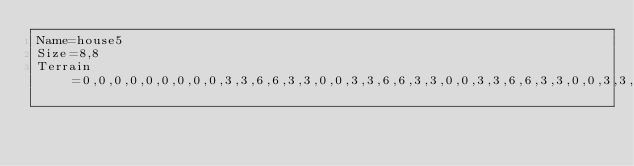Convert code to text. <code><loc_0><loc_0><loc_500><loc_500><_YAML_>Name=house5
Size=8,8
Terrain=0,0,0,0,0,0,0,0,0,3,3,6,6,3,3,0,0,3,3,6,6,3,3,0,0,3,3,6,6,3,3,0,0,3,3,6,6,3,3,0,0,3,3,6,6,3,3,0,0,3,3,6,6,3,3,0,0,0,0,0,0,0,0,0</code> 